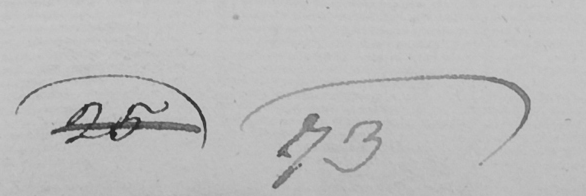What text is written in this handwritten line? 25 73 